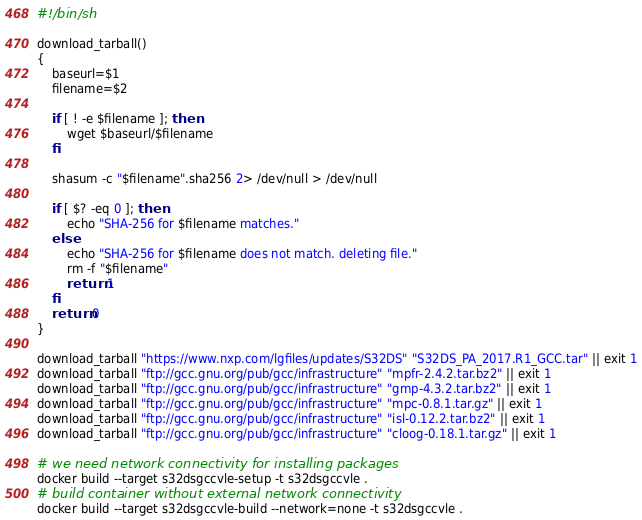<code> <loc_0><loc_0><loc_500><loc_500><_Bash_>#!/bin/sh

download_tarball()
{
	baseurl=$1
	filename=$2

	if [ ! -e $filename ]; then
		wget $baseurl/$filename
	fi

	shasum -c "$filename".sha256 2> /dev/null > /dev/null

	if [ $? -eq 0 ]; then
		echo "SHA-256 for $filename matches."
	else
		echo "SHA-256 for $filename does not match. deleting file."
		rm -f "$filename"
		return 1
	fi
	return 0
}

download_tarball "https://www.nxp.com/lgfiles/updates/S32DS" "S32DS_PA_2017.R1_GCC.tar" || exit 1
download_tarball "ftp://gcc.gnu.org/pub/gcc/infrastructure" "mpfr-2.4.2.tar.bz2" || exit 1
download_tarball "ftp://gcc.gnu.org/pub/gcc/infrastructure" "gmp-4.3.2.tar.bz2" || exit 1
download_tarball "ftp://gcc.gnu.org/pub/gcc/infrastructure" "mpc-0.8.1.tar.gz" || exit 1
download_tarball "ftp://gcc.gnu.org/pub/gcc/infrastructure" "isl-0.12.2.tar.bz2" || exit 1
download_tarball "ftp://gcc.gnu.org/pub/gcc/infrastructure" "cloog-0.18.1.tar.gz" || exit 1

# we need network connectivity for installing packages
docker build --target s32dsgccvle-setup -t s32dsgccvle .
# build container without external network connectivity
docker build --target s32dsgccvle-build --network=none -t s32dsgccvle .
</code> 